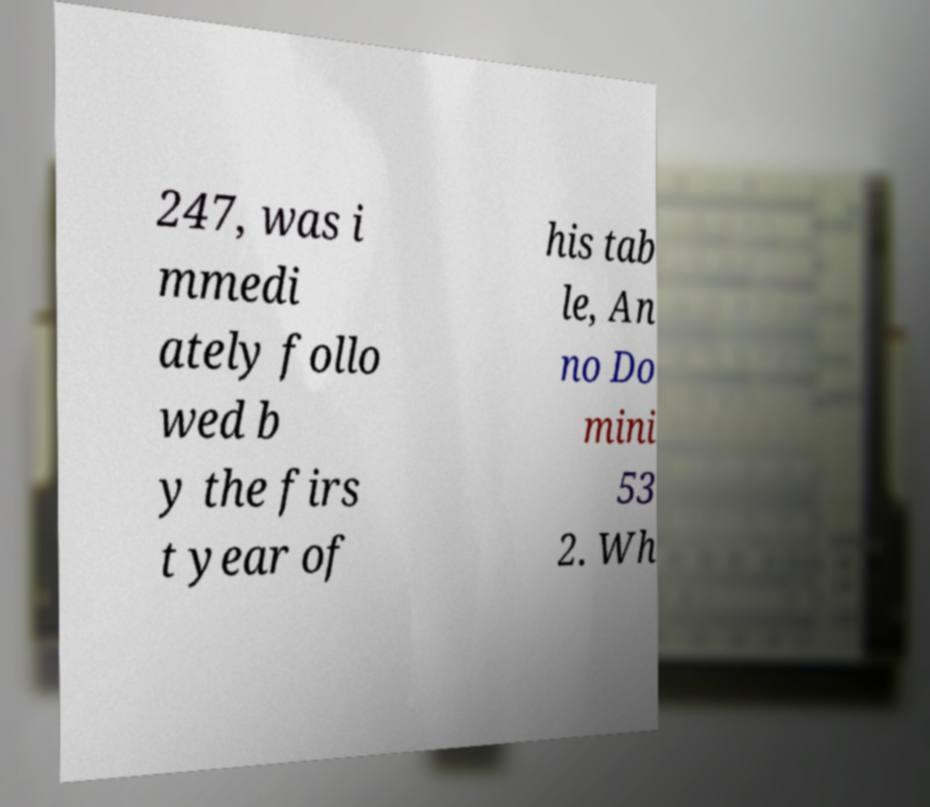Please read and relay the text visible in this image. What does it say? 247, was i mmedi ately follo wed b y the firs t year of his tab le, An no Do mini 53 2. Wh 